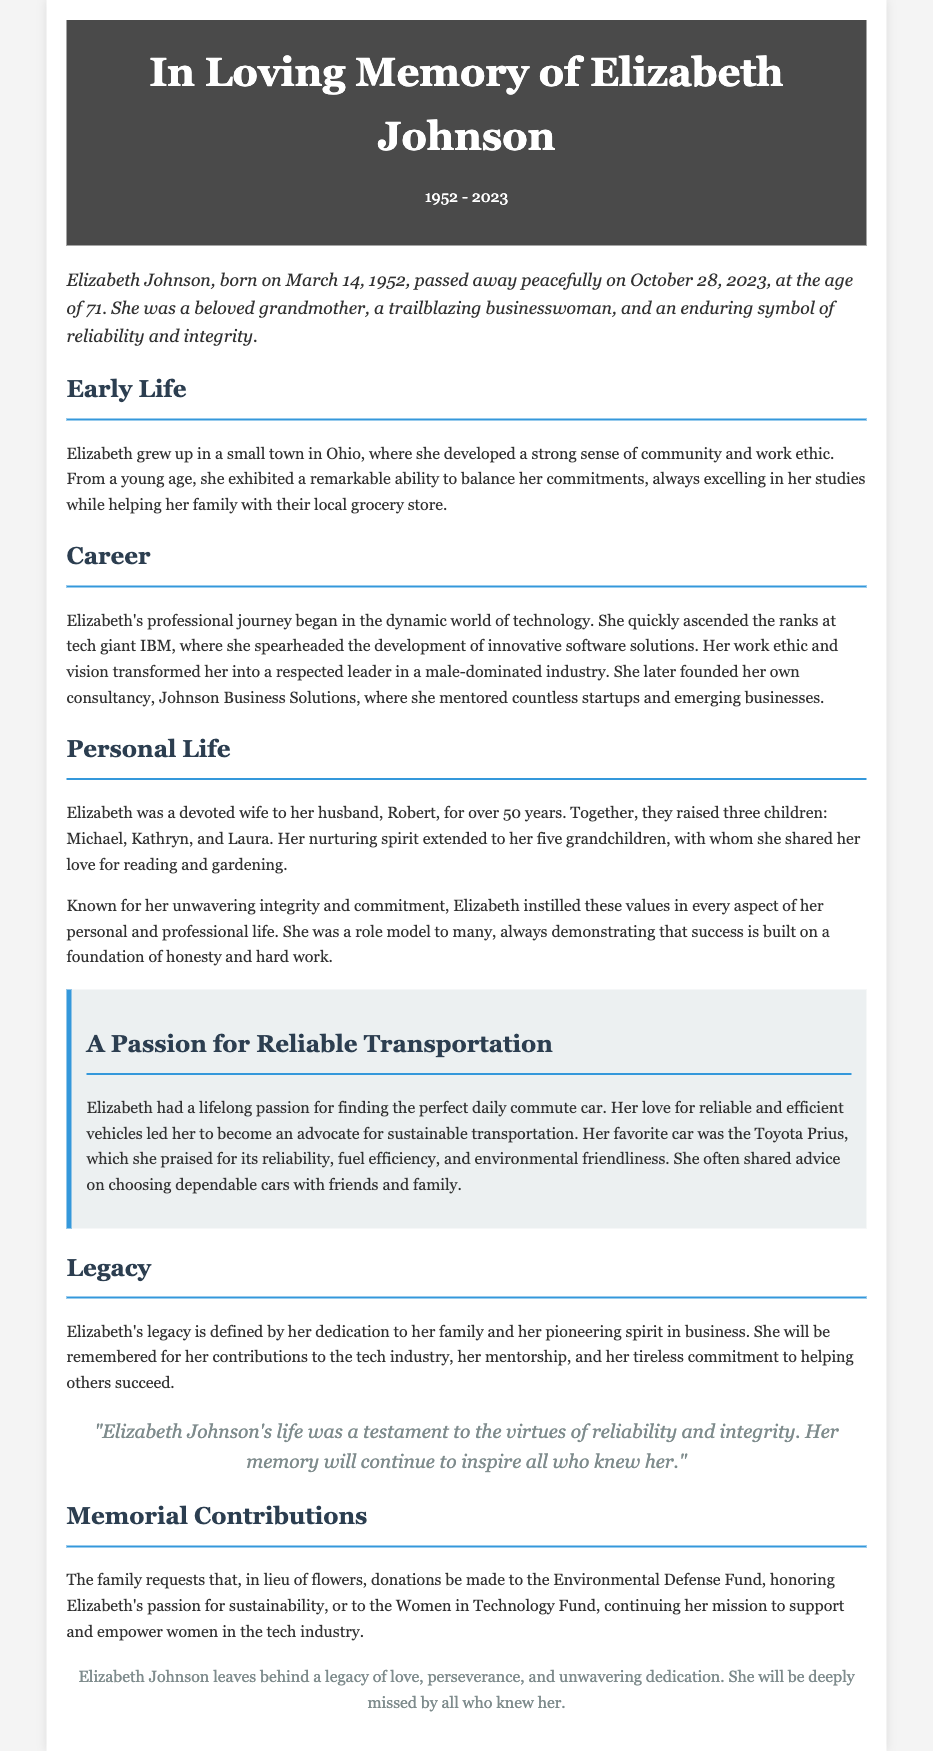what year was Elizabeth Johnson born? The document states that Elizabeth Johnson was born on March 14, 1952.
Answer: 1952 how many children did Elizabeth have? The document mentions that Elizabeth and her husband raised three children.
Answer: three what was Elizabeth's favorite car? The document specifies that her favorite car was the Toyota Prius.
Answer: Toyota Prius what industry did Elizabeth pioneer in? The document describes her as a trailblazing businesswoman in the technology industry.
Answer: technology what was one of Elizabeth's professional roles? The document notes her role as a consultant after founding Johnson Business Solutions.
Answer: consultant how many grandchildren did Elizabeth have? The document states that she had five grandchildren.
Answer: five which organization is mentioned for memorial contributions? The document highlights the Environmental Defense Fund for memorial contributions.
Answer: Environmental Defense Fund what qualities was Elizabeth Johnson known for? The document highlights her reliability and integrity.
Answer: reliability and integrity what is a personal interest of Elizabeth mentioned in the obituary? The document mentions her passion for finding the perfect daily commute car.
Answer: daily commute car 